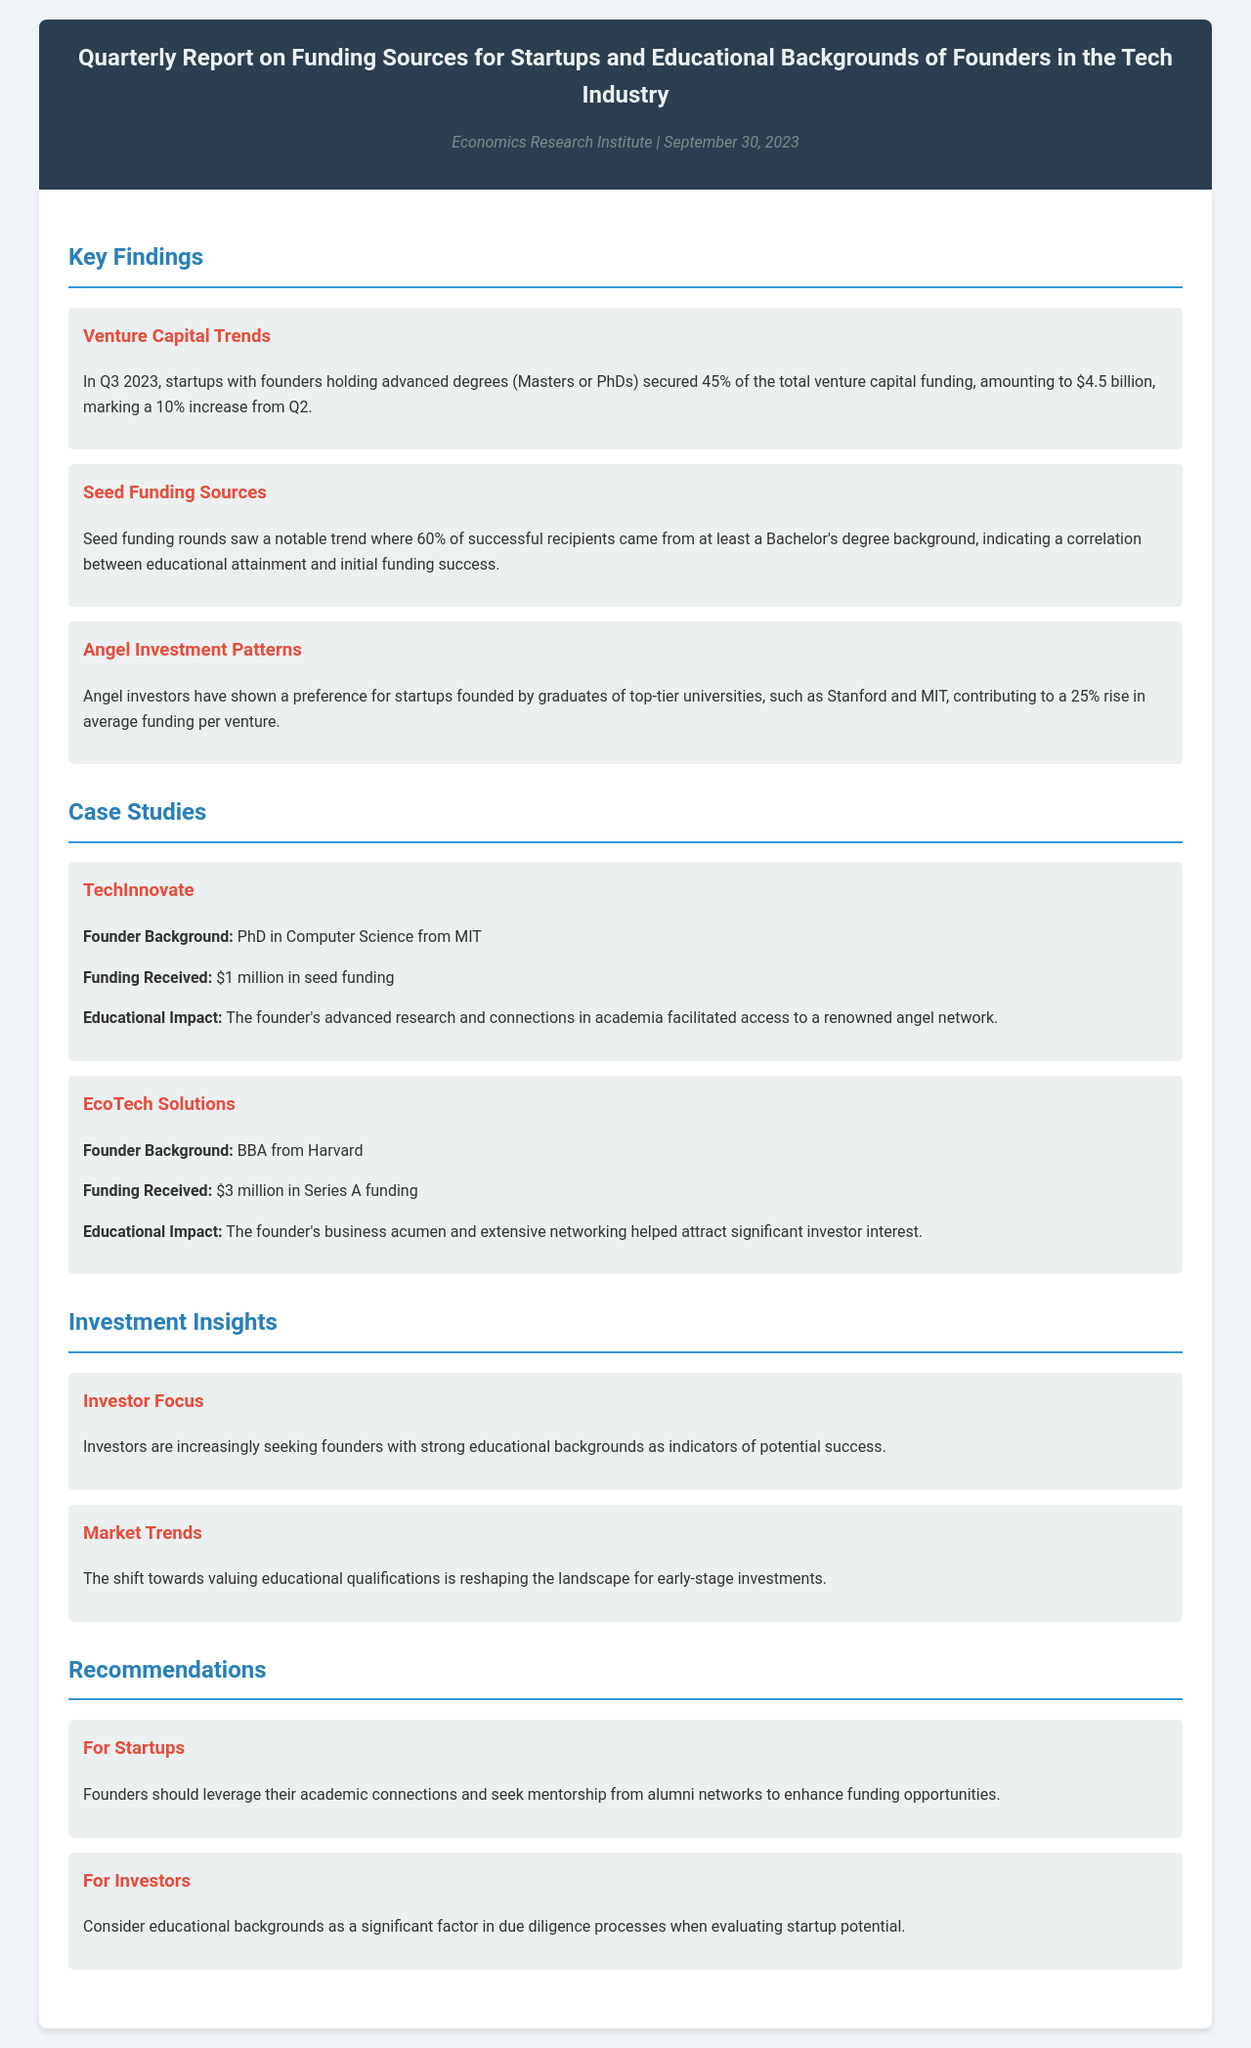What percentage of venture capital funding was secured by founders with advanced degrees? The document states that startups with founders holding advanced degrees secured 45% of the total venture capital funding.
Answer: 45% What was the amount of venture capital funding secured by those with advanced degrees? The document mentions that this funding amounted to $4.5 billion in Q3 2023.
Answer: $4.5 billion What percentage of successful seed funding recipients had at least a Bachelor's degree? The report indicates that 60% of successful recipients had at least a Bachelor's degree.
Answer: 60% Which universities are preferred by angel investors according to the report? The document notes that angel investors show a preference for graduates from top-tier universities like Stanford and MIT.
Answer: Stanford and MIT What is the funding amount received by TechInnovate? The document specifies that TechInnovate received $1 million in seed funding.
Answer: $1 million How does the founder's background in EcoTech Solutions relate to their funding success? The document states that the founder's business acumen and networking helped attract significant investor interest, indicating the impact of educational background.
Answer: Business acumen and networking What is one key insight regarding investor focus mentioned in the report? The document mentions that investors are increasingly seeking founders with strong educational backgrounds as indicators of potential success.
Answer: Strong educational backgrounds What is the recommendation for startups regarding funding opportunities? The report recommends that founders should leverage their academic connections and seek mentorship from alumni networks.
Answer: Leverage academic connections What type of funding saw notable trends related to educational attainment? The document highlights that seed funding rounds reflected a correlation between educational attainment and funding success.
Answer: Seed funding 